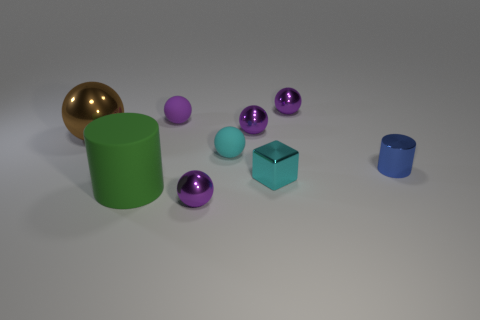How many purple balls must be subtracted to get 1 purple balls? 3 Subtract all cyan blocks. How many purple balls are left? 4 Subtract all cyan spheres. How many spheres are left? 5 Subtract all large brown spheres. How many spheres are left? 5 Subtract all yellow spheres. Subtract all green cylinders. How many spheres are left? 6 Add 1 cyan spheres. How many objects exist? 10 Subtract all spheres. How many objects are left? 3 Add 1 big metallic spheres. How many big metallic spheres are left? 2 Add 5 large brown metal spheres. How many large brown metal spheres exist? 6 Subtract 0 yellow blocks. How many objects are left? 9 